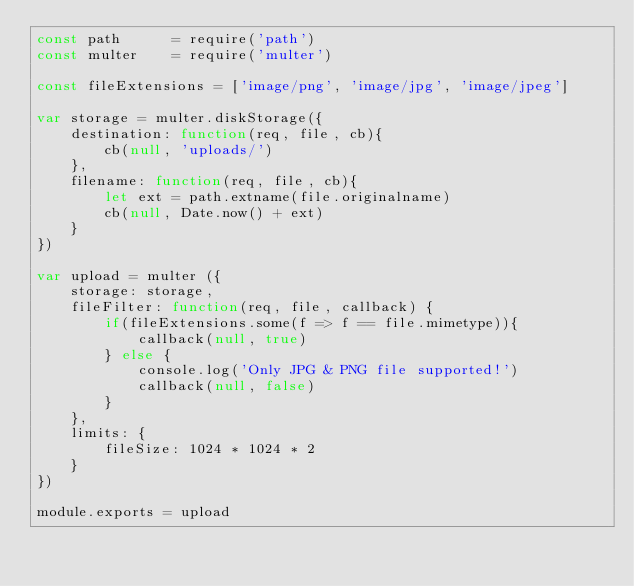<code> <loc_0><loc_0><loc_500><loc_500><_JavaScript_>const path      = require('path')
const multer    = require('multer')

const fileExtensions = ['image/png', 'image/jpg', 'image/jpeg']

var storage = multer.diskStorage({
    destination: function(req, file, cb){
        cb(null, 'uploads/')
    },
    filename: function(req, file, cb){
        let ext = path.extname(file.originalname)
        cb(null, Date.now() + ext)
    }
})

var upload = multer ({
    storage: storage,
    fileFilter: function(req, file, callback) {
        if(fileExtensions.some(f => f == file.mimetype)){
            callback(null, true)
        } else {
            console.log('Only JPG & PNG file supported!')
            callback(null, false)
        }
    },
    limits: {
        fileSize: 1024 * 1024 * 2
    }
})

module.exports = upload</code> 